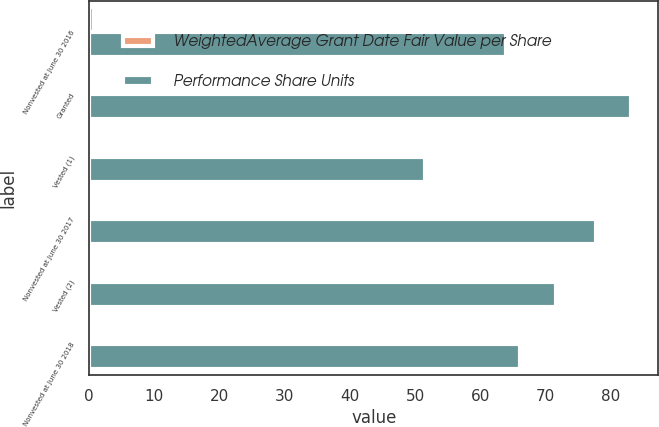Convert chart to OTSL. <chart><loc_0><loc_0><loc_500><loc_500><stacked_bar_chart><ecel><fcel>Nonvested at June 30 2016<fcel>Granted<fcel>Vested (1)<fcel>Nonvested at June 30 2017<fcel>Vested (2)<fcel>Nonvested at June 30 2018<nl><fcel>WeightedAverage Grant Date Fair Value per Share<fcel>0.8<fcel>0.2<fcel>0.4<fcel>0.6<fcel>0.2<fcel>0.4<nl><fcel>Performance Share Units<fcel>63.96<fcel>83.19<fcel>51.49<fcel>77.83<fcel>71.57<fcel>66.13<nl></chart> 